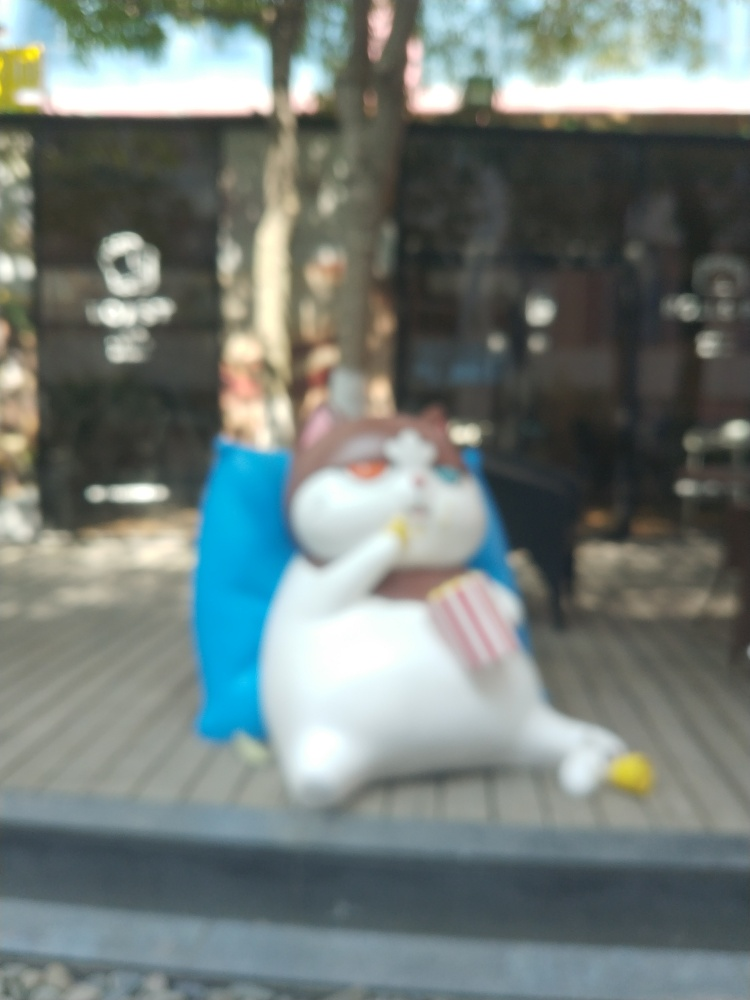What is the main subject in this photo? The main subject is a blurry figure which seems to be a statue of a relaxed, seated cat-like character, holding something in its left hand. Can you tell me more about its setting? Although details are obscured due to the blurriness, the figure is placed outdoors, with a dark fence and some greenery in the background which could indicate a garden or park setting. 